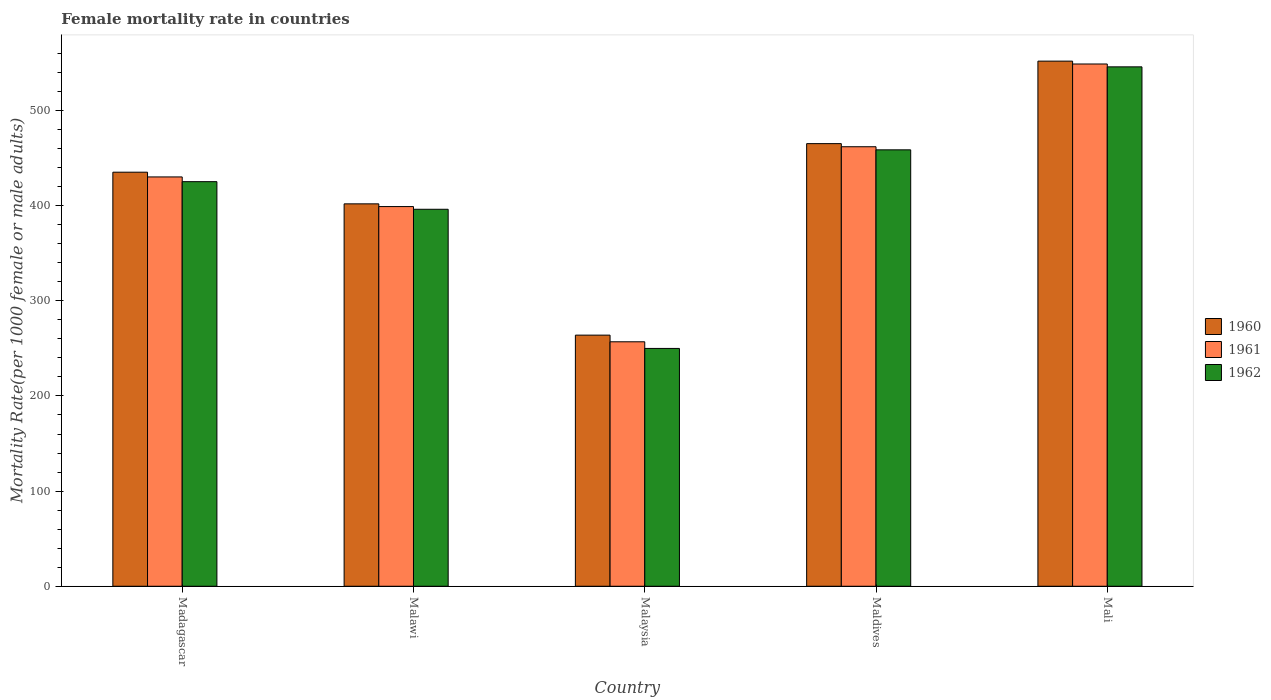How many groups of bars are there?
Offer a terse response. 5. Are the number of bars on each tick of the X-axis equal?
Keep it short and to the point. Yes. What is the label of the 4th group of bars from the left?
Offer a terse response. Maldives. In how many cases, is the number of bars for a given country not equal to the number of legend labels?
Provide a short and direct response. 0. What is the female mortality rate in 1962 in Malaysia?
Provide a succinct answer. 249.93. Across all countries, what is the maximum female mortality rate in 1961?
Your response must be concise. 548.86. Across all countries, what is the minimum female mortality rate in 1960?
Make the answer very short. 263.9. In which country was the female mortality rate in 1962 maximum?
Give a very brief answer. Mali. In which country was the female mortality rate in 1960 minimum?
Your answer should be very brief. Malaysia. What is the total female mortality rate in 1960 in the graph?
Your answer should be very brief. 2117.95. What is the difference between the female mortality rate in 1960 in Malawi and that in Malaysia?
Give a very brief answer. 137.97. What is the difference between the female mortality rate in 1960 in Malawi and the female mortality rate in 1962 in Mali?
Offer a terse response. -143.98. What is the average female mortality rate in 1960 per country?
Offer a very short reply. 423.59. What is the difference between the female mortality rate of/in 1960 and female mortality rate of/in 1961 in Madagascar?
Give a very brief answer. 4.97. What is the ratio of the female mortality rate in 1960 in Madagascar to that in Malawi?
Give a very brief answer. 1.08. Is the female mortality rate in 1960 in Madagascar less than that in Malawi?
Provide a short and direct response. No. Is the difference between the female mortality rate in 1960 in Malawi and Mali greater than the difference between the female mortality rate in 1961 in Malawi and Mali?
Offer a terse response. No. What is the difference between the highest and the second highest female mortality rate in 1960?
Provide a short and direct response. 30.03. What is the difference between the highest and the lowest female mortality rate in 1962?
Offer a very short reply. 295.93. In how many countries, is the female mortality rate in 1960 greater than the average female mortality rate in 1960 taken over all countries?
Keep it short and to the point. 3. What does the 3rd bar from the right in Malaysia represents?
Your response must be concise. 1960. How many countries are there in the graph?
Give a very brief answer. 5. What is the difference between two consecutive major ticks on the Y-axis?
Provide a succinct answer. 100. Does the graph contain grids?
Make the answer very short. No. Where does the legend appear in the graph?
Offer a terse response. Center right. How many legend labels are there?
Provide a succinct answer. 3. What is the title of the graph?
Provide a succinct answer. Female mortality rate in countries. What is the label or title of the X-axis?
Offer a terse response. Country. What is the label or title of the Y-axis?
Provide a short and direct response. Mortality Rate(per 1000 female or male adults). What is the Mortality Rate(per 1000 female or male adults) in 1960 in Madagascar?
Your answer should be very brief. 435.14. What is the Mortality Rate(per 1000 female or male adults) of 1961 in Madagascar?
Your answer should be very brief. 430.17. What is the Mortality Rate(per 1000 female or male adults) in 1962 in Madagascar?
Your answer should be very brief. 425.19. What is the Mortality Rate(per 1000 female or male adults) of 1960 in Malawi?
Ensure brevity in your answer.  401.87. What is the Mortality Rate(per 1000 female or male adults) in 1961 in Malawi?
Keep it short and to the point. 399.02. What is the Mortality Rate(per 1000 female or male adults) of 1962 in Malawi?
Provide a short and direct response. 396.18. What is the Mortality Rate(per 1000 female or male adults) in 1960 in Malaysia?
Ensure brevity in your answer.  263.9. What is the Mortality Rate(per 1000 female or male adults) in 1961 in Malaysia?
Ensure brevity in your answer.  256.92. What is the Mortality Rate(per 1000 female or male adults) in 1962 in Malaysia?
Provide a short and direct response. 249.93. What is the Mortality Rate(per 1000 female or male adults) in 1960 in Maldives?
Your response must be concise. 465.17. What is the Mortality Rate(per 1000 female or male adults) in 1961 in Maldives?
Keep it short and to the point. 461.9. What is the Mortality Rate(per 1000 female or male adults) in 1962 in Maldives?
Your answer should be very brief. 458.64. What is the Mortality Rate(per 1000 female or male adults) of 1960 in Mali?
Offer a very short reply. 551.87. What is the Mortality Rate(per 1000 female or male adults) of 1961 in Mali?
Keep it short and to the point. 548.86. What is the Mortality Rate(per 1000 female or male adults) in 1962 in Mali?
Keep it short and to the point. 545.86. Across all countries, what is the maximum Mortality Rate(per 1000 female or male adults) of 1960?
Offer a very short reply. 551.87. Across all countries, what is the maximum Mortality Rate(per 1000 female or male adults) of 1961?
Make the answer very short. 548.86. Across all countries, what is the maximum Mortality Rate(per 1000 female or male adults) of 1962?
Ensure brevity in your answer.  545.86. Across all countries, what is the minimum Mortality Rate(per 1000 female or male adults) in 1960?
Ensure brevity in your answer.  263.9. Across all countries, what is the minimum Mortality Rate(per 1000 female or male adults) in 1961?
Give a very brief answer. 256.92. Across all countries, what is the minimum Mortality Rate(per 1000 female or male adults) of 1962?
Your answer should be very brief. 249.93. What is the total Mortality Rate(per 1000 female or male adults) in 1960 in the graph?
Give a very brief answer. 2117.95. What is the total Mortality Rate(per 1000 female or male adults) in 1961 in the graph?
Your response must be concise. 2096.87. What is the total Mortality Rate(per 1000 female or male adults) in 1962 in the graph?
Offer a terse response. 2075.79. What is the difference between the Mortality Rate(per 1000 female or male adults) in 1960 in Madagascar and that in Malawi?
Provide a short and direct response. 33.26. What is the difference between the Mortality Rate(per 1000 female or male adults) of 1961 in Madagascar and that in Malawi?
Provide a succinct answer. 31.14. What is the difference between the Mortality Rate(per 1000 female or male adults) in 1962 in Madagascar and that in Malawi?
Provide a succinct answer. 29.02. What is the difference between the Mortality Rate(per 1000 female or male adults) in 1960 in Madagascar and that in Malaysia?
Your answer should be very brief. 171.23. What is the difference between the Mortality Rate(per 1000 female or male adults) in 1961 in Madagascar and that in Malaysia?
Offer a very short reply. 173.25. What is the difference between the Mortality Rate(per 1000 female or male adults) in 1962 in Madagascar and that in Malaysia?
Your answer should be compact. 175.26. What is the difference between the Mortality Rate(per 1000 female or male adults) of 1960 in Madagascar and that in Maldives?
Make the answer very short. -30.03. What is the difference between the Mortality Rate(per 1000 female or male adults) of 1961 in Madagascar and that in Maldives?
Your answer should be compact. -31.74. What is the difference between the Mortality Rate(per 1000 female or male adults) in 1962 in Madagascar and that in Maldives?
Your answer should be very brief. -33.44. What is the difference between the Mortality Rate(per 1000 female or male adults) in 1960 in Madagascar and that in Mali?
Your answer should be very brief. -116.73. What is the difference between the Mortality Rate(per 1000 female or male adults) of 1961 in Madagascar and that in Mali?
Keep it short and to the point. -118.69. What is the difference between the Mortality Rate(per 1000 female or male adults) in 1962 in Madagascar and that in Mali?
Provide a short and direct response. -120.66. What is the difference between the Mortality Rate(per 1000 female or male adults) of 1960 in Malawi and that in Malaysia?
Offer a terse response. 137.97. What is the difference between the Mortality Rate(per 1000 female or male adults) of 1961 in Malawi and that in Malaysia?
Your answer should be very brief. 142.11. What is the difference between the Mortality Rate(per 1000 female or male adults) of 1962 in Malawi and that in Malaysia?
Give a very brief answer. 146.25. What is the difference between the Mortality Rate(per 1000 female or male adults) in 1960 in Malawi and that in Maldives?
Your response must be concise. -63.29. What is the difference between the Mortality Rate(per 1000 female or male adults) in 1961 in Malawi and that in Maldives?
Provide a succinct answer. -62.88. What is the difference between the Mortality Rate(per 1000 female or male adults) of 1962 in Malawi and that in Maldives?
Your response must be concise. -62.46. What is the difference between the Mortality Rate(per 1000 female or male adults) of 1960 in Malawi and that in Mali?
Offer a very short reply. -149.99. What is the difference between the Mortality Rate(per 1000 female or male adults) in 1961 in Malawi and that in Mali?
Your response must be concise. -149.84. What is the difference between the Mortality Rate(per 1000 female or male adults) of 1962 in Malawi and that in Mali?
Keep it short and to the point. -149.68. What is the difference between the Mortality Rate(per 1000 female or male adults) of 1960 in Malaysia and that in Maldives?
Provide a succinct answer. -201.26. What is the difference between the Mortality Rate(per 1000 female or male adults) of 1961 in Malaysia and that in Maldives?
Provide a short and direct response. -204.98. What is the difference between the Mortality Rate(per 1000 female or male adults) of 1962 in Malaysia and that in Maldives?
Your response must be concise. -208.71. What is the difference between the Mortality Rate(per 1000 female or male adults) in 1960 in Malaysia and that in Mali?
Provide a short and direct response. -287.96. What is the difference between the Mortality Rate(per 1000 female or male adults) in 1961 in Malaysia and that in Mali?
Your answer should be compact. -291.94. What is the difference between the Mortality Rate(per 1000 female or male adults) in 1962 in Malaysia and that in Mali?
Offer a very short reply. -295.93. What is the difference between the Mortality Rate(per 1000 female or male adults) in 1960 in Maldives and that in Mali?
Provide a short and direct response. -86.7. What is the difference between the Mortality Rate(per 1000 female or male adults) of 1961 in Maldives and that in Mali?
Provide a succinct answer. -86.96. What is the difference between the Mortality Rate(per 1000 female or male adults) of 1962 in Maldives and that in Mali?
Offer a very short reply. -87.22. What is the difference between the Mortality Rate(per 1000 female or male adults) in 1960 in Madagascar and the Mortality Rate(per 1000 female or male adults) in 1961 in Malawi?
Provide a short and direct response. 36.11. What is the difference between the Mortality Rate(per 1000 female or male adults) of 1960 in Madagascar and the Mortality Rate(per 1000 female or male adults) of 1962 in Malawi?
Ensure brevity in your answer.  38.96. What is the difference between the Mortality Rate(per 1000 female or male adults) of 1961 in Madagascar and the Mortality Rate(per 1000 female or male adults) of 1962 in Malawi?
Offer a terse response. 33.99. What is the difference between the Mortality Rate(per 1000 female or male adults) of 1960 in Madagascar and the Mortality Rate(per 1000 female or male adults) of 1961 in Malaysia?
Keep it short and to the point. 178.22. What is the difference between the Mortality Rate(per 1000 female or male adults) in 1960 in Madagascar and the Mortality Rate(per 1000 female or male adults) in 1962 in Malaysia?
Provide a short and direct response. 185.21. What is the difference between the Mortality Rate(per 1000 female or male adults) of 1961 in Madagascar and the Mortality Rate(per 1000 female or male adults) of 1962 in Malaysia?
Ensure brevity in your answer.  180.24. What is the difference between the Mortality Rate(per 1000 female or male adults) of 1960 in Madagascar and the Mortality Rate(per 1000 female or male adults) of 1961 in Maldives?
Your answer should be compact. -26.77. What is the difference between the Mortality Rate(per 1000 female or male adults) of 1960 in Madagascar and the Mortality Rate(per 1000 female or male adults) of 1962 in Maldives?
Keep it short and to the point. -23.5. What is the difference between the Mortality Rate(per 1000 female or male adults) in 1961 in Madagascar and the Mortality Rate(per 1000 female or male adults) in 1962 in Maldives?
Provide a succinct answer. -28.47. What is the difference between the Mortality Rate(per 1000 female or male adults) of 1960 in Madagascar and the Mortality Rate(per 1000 female or male adults) of 1961 in Mali?
Your answer should be compact. -113.72. What is the difference between the Mortality Rate(per 1000 female or male adults) in 1960 in Madagascar and the Mortality Rate(per 1000 female or male adults) in 1962 in Mali?
Your response must be concise. -110.72. What is the difference between the Mortality Rate(per 1000 female or male adults) of 1961 in Madagascar and the Mortality Rate(per 1000 female or male adults) of 1962 in Mali?
Your answer should be very brief. -115.69. What is the difference between the Mortality Rate(per 1000 female or male adults) in 1960 in Malawi and the Mortality Rate(per 1000 female or male adults) in 1961 in Malaysia?
Keep it short and to the point. 144.96. What is the difference between the Mortality Rate(per 1000 female or male adults) in 1960 in Malawi and the Mortality Rate(per 1000 female or male adults) in 1962 in Malaysia?
Keep it short and to the point. 151.95. What is the difference between the Mortality Rate(per 1000 female or male adults) of 1961 in Malawi and the Mortality Rate(per 1000 female or male adults) of 1962 in Malaysia?
Your response must be concise. 149.1. What is the difference between the Mortality Rate(per 1000 female or male adults) of 1960 in Malawi and the Mortality Rate(per 1000 female or male adults) of 1961 in Maldives?
Give a very brief answer. -60.03. What is the difference between the Mortality Rate(per 1000 female or male adults) of 1960 in Malawi and the Mortality Rate(per 1000 female or male adults) of 1962 in Maldives?
Your answer should be compact. -56.76. What is the difference between the Mortality Rate(per 1000 female or male adults) in 1961 in Malawi and the Mortality Rate(per 1000 female or male adults) in 1962 in Maldives?
Keep it short and to the point. -59.61. What is the difference between the Mortality Rate(per 1000 female or male adults) of 1960 in Malawi and the Mortality Rate(per 1000 female or male adults) of 1961 in Mali?
Your answer should be very brief. -146.99. What is the difference between the Mortality Rate(per 1000 female or male adults) of 1960 in Malawi and the Mortality Rate(per 1000 female or male adults) of 1962 in Mali?
Your answer should be very brief. -143.98. What is the difference between the Mortality Rate(per 1000 female or male adults) of 1961 in Malawi and the Mortality Rate(per 1000 female or male adults) of 1962 in Mali?
Offer a terse response. -146.83. What is the difference between the Mortality Rate(per 1000 female or male adults) in 1960 in Malaysia and the Mortality Rate(per 1000 female or male adults) in 1961 in Maldives?
Your answer should be very brief. -198. What is the difference between the Mortality Rate(per 1000 female or male adults) of 1960 in Malaysia and the Mortality Rate(per 1000 female or male adults) of 1962 in Maldives?
Give a very brief answer. -194.73. What is the difference between the Mortality Rate(per 1000 female or male adults) of 1961 in Malaysia and the Mortality Rate(per 1000 female or male adults) of 1962 in Maldives?
Make the answer very short. -201.72. What is the difference between the Mortality Rate(per 1000 female or male adults) of 1960 in Malaysia and the Mortality Rate(per 1000 female or male adults) of 1961 in Mali?
Provide a succinct answer. -284.95. What is the difference between the Mortality Rate(per 1000 female or male adults) of 1960 in Malaysia and the Mortality Rate(per 1000 female or male adults) of 1962 in Mali?
Your answer should be very brief. -281.95. What is the difference between the Mortality Rate(per 1000 female or male adults) of 1961 in Malaysia and the Mortality Rate(per 1000 female or male adults) of 1962 in Mali?
Provide a short and direct response. -288.94. What is the difference between the Mortality Rate(per 1000 female or male adults) in 1960 in Maldives and the Mortality Rate(per 1000 female or male adults) in 1961 in Mali?
Make the answer very short. -83.69. What is the difference between the Mortality Rate(per 1000 female or male adults) in 1960 in Maldives and the Mortality Rate(per 1000 female or male adults) in 1962 in Mali?
Provide a succinct answer. -80.69. What is the difference between the Mortality Rate(per 1000 female or male adults) of 1961 in Maldives and the Mortality Rate(per 1000 female or male adults) of 1962 in Mali?
Keep it short and to the point. -83.95. What is the average Mortality Rate(per 1000 female or male adults) in 1960 per country?
Offer a terse response. 423.59. What is the average Mortality Rate(per 1000 female or male adults) of 1961 per country?
Your answer should be compact. 419.37. What is the average Mortality Rate(per 1000 female or male adults) in 1962 per country?
Give a very brief answer. 415.16. What is the difference between the Mortality Rate(per 1000 female or male adults) of 1960 and Mortality Rate(per 1000 female or male adults) of 1961 in Madagascar?
Provide a succinct answer. 4.97. What is the difference between the Mortality Rate(per 1000 female or male adults) in 1960 and Mortality Rate(per 1000 female or male adults) in 1962 in Madagascar?
Make the answer very short. 9.94. What is the difference between the Mortality Rate(per 1000 female or male adults) of 1961 and Mortality Rate(per 1000 female or male adults) of 1962 in Madagascar?
Your answer should be compact. 4.97. What is the difference between the Mortality Rate(per 1000 female or male adults) of 1960 and Mortality Rate(per 1000 female or male adults) of 1961 in Malawi?
Your answer should be compact. 2.85. What is the difference between the Mortality Rate(per 1000 female or male adults) in 1960 and Mortality Rate(per 1000 female or male adults) in 1962 in Malawi?
Offer a terse response. 5.7. What is the difference between the Mortality Rate(per 1000 female or male adults) in 1961 and Mortality Rate(per 1000 female or male adults) in 1962 in Malawi?
Keep it short and to the point. 2.85. What is the difference between the Mortality Rate(per 1000 female or male adults) in 1960 and Mortality Rate(per 1000 female or male adults) in 1961 in Malaysia?
Give a very brief answer. 6.99. What is the difference between the Mortality Rate(per 1000 female or male adults) in 1960 and Mortality Rate(per 1000 female or male adults) in 1962 in Malaysia?
Your answer should be compact. 13.98. What is the difference between the Mortality Rate(per 1000 female or male adults) in 1961 and Mortality Rate(per 1000 female or male adults) in 1962 in Malaysia?
Offer a very short reply. 6.99. What is the difference between the Mortality Rate(per 1000 female or male adults) in 1960 and Mortality Rate(per 1000 female or male adults) in 1961 in Maldives?
Your answer should be compact. 3.27. What is the difference between the Mortality Rate(per 1000 female or male adults) in 1960 and Mortality Rate(per 1000 female or male adults) in 1962 in Maldives?
Offer a very short reply. 6.53. What is the difference between the Mortality Rate(per 1000 female or male adults) in 1961 and Mortality Rate(per 1000 female or male adults) in 1962 in Maldives?
Provide a succinct answer. 3.27. What is the difference between the Mortality Rate(per 1000 female or male adults) of 1960 and Mortality Rate(per 1000 female or male adults) of 1961 in Mali?
Provide a succinct answer. 3. What is the difference between the Mortality Rate(per 1000 female or male adults) of 1960 and Mortality Rate(per 1000 female or male adults) of 1962 in Mali?
Provide a succinct answer. 6.01. What is the difference between the Mortality Rate(per 1000 female or male adults) of 1961 and Mortality Rate(per 1000 female or male adults) of 1962 in Mali?
Provide a succinct answer. 3. What is the ratio of the Mortality Rate(per 1000 female or male adults) in 1960 in Madagascar to that in Malawi?
Offer a very short reply. 1.08. What is the ratio of the Mortality Rate(per 1000 female or male adults) of 1961 in Madagascar to that in Malawi?
Give a very brief answer. 1.08. What is the ratio of the Mortality Rate(per 1000 female or male adults) in 1962 in Madagascar to that in Malawi?
Your response must be concise. 1.07. What is the ratio of the Mortality Rate(per 1000 female or male adults) of 1960 in Madagascar to that in Malaysia?
Make the answer very short. 1.65. What is the ratio of the Mortality Rate(per 1000 female or male adults) of 1961 in Madagascar to that in Malaysia?
Ensure brevity in your answer.  1.67. What is the ratio of the Mortality Rate(per 1000 female or male adults) of 1962 in Madagascar to that in Malaysia?
Give a very brief answer. 1.7. What is the ratio of the Mortality Rate(per 1000 female or male adults) in 1960 in Madagascar to that in Maldives?
Give a very brief answer. 0.94. What is the ratio of the Mortality Rate(per 1000 female or male adults) in 1961 in Madagascar to that in Maldives?
Keep it short and to the point. 0.93. What is the ratio of the Mortality Rate(per 1000 female or male adults) of 1962 in Madagascar to that in Maldives?
Keep it short and to the point. 0.93. What is the ratio of the Mortality Rate(per 1000 female or male adults) in 1960 in Madagascar to that in Mali?
Provide a succinct answer. 0.79. What is the ratio of the Mortality Rate(per 1000 female or male adults) of 1961 in Madagascar to that in Mali?
Offer a terse response. 0.78. What is the ratio of the Mortality Rate(per 1000 female or male adults) in 1962 in Madagascar to that in Mali?
Your answer should be compact. 0.78. What is the ratio of the Mortality Rate(per 1000 female or male adults) of 1960 in Malawi to that in Malaysia?
Offer a terse response. 1.52. What is the ratio of the Mortality Rate(per 1000 female or male adults) of 1961 in Malawi to that in Malaysia?
Ensure brevity in your answer.  1.55. What is the ratio of the Mortality Rate(per 1000 female or male adults) in 1962 in Malawi to that in Malaysia?
Your response must be concise. 1.59. What is the ratio of the Mortality Rate(per 1000 female or male adults) in 1960 in Malawi to that in Maldives?
Provide a short and direct response. 0.86. What is the ratio of the Mortality Rate(per 1000 female or male adults) of 1961 in Malawi to that in Maldives?
Make the answer very short. 0.86. What is the ratio of the Mortality Rate(per 1000 female or male adults) in 1962 in Malawi to that in Maldives?
Offer a very short reply. 0.86. What is the ratio of the Mortality Rate(per 1000 female or male adults) in 1960 in Malawi to that in Mali?
Ensure brevity in your answer.  0.73. What is the ratio of the Mortality Rate(per 1000 female or male adults) in 1961 in Malawi to that in Mali?
Ensure brevity in your answer.  0.73. What is the ratio of the Mortality Rate(per 1000 female or male adults) in 1962 in Malawi to that in Mali?
Offer a very short reply. 0.73. What is the ratio of the Mortality Rate(per 1000 female or male adults) in 1960 in Malaysia to that in Maldives?
Provide a succinct answer. 0.57. What is the ratio of the Mortality Rate(per 1000 female or male adults) in 1961 in Malaysia to that in Maldives?
Offer a terse response. 0.56. What is the ratio of the Mortality Rate(per 1000 female or male adults) of 1962 in Malaysia to that in Maldives?
Offer a very short reply. 0.54. What is the ratio of the Mortality Rate(per 1000 female or male adults) of 1960 in Malaysia to that in Mali?
Your answer should be compact. 0.48. What is the ratio of the Mortality Rate(per 1000 female or male adults) of 1961 in Malaysia to that in Mali?
Ensure brevity in your answer.  0.47. What is the ratio of the Mortality Rate(per 1000 female or male adults) in 1962 in Malaysia to that in Mali?
Your answer should be very brief. 0.46. What is the ratio of the Mortality Rate(per 1000 female or male adults) in 1960 in Maldives to that in Mali?
Make the answer very short. 0.84. What is the ratio of the Mortality Rate(per 1000 female or male adults) of 1961 in Maldives to that in Mali?
Provide a short and direct response. 0.84. What is the ratio of the Mortality Rate(per 1000 female or male adults) in 1962 in Maldives to that in Mali?
Keep it short and to the point. 0.84. What is the difference between the highest and the second highest Mortality Rate(per 1000 female or male adults) in 1960?
Provide a succinct answer. 86.7. What is the difference between the highest and the second highest Mortality Rate(per 1000 female or male adults) of 1961?
Provide a short and direct response. 86.96. What is the difference between the highest and the second highest Mortality Rate(per 1000 female or male adults) of 1962?
Provide a short and direct response. 87.22. What is the difference between the highest and the lowest Mortality Rate(per 1000 female or male adults) in 1960?
Provide a succinct answer. 287.96. What is the difference between the highest and the lowest Mortality Rate(per 1000 female or male adults) in 1961?
Offer a terse response. 291.94. What is the difference between the highest and the lowest Mortality Rate(per 1000 female or male adults) in 1962?
Ensure brevity in your answer.  295.93. 